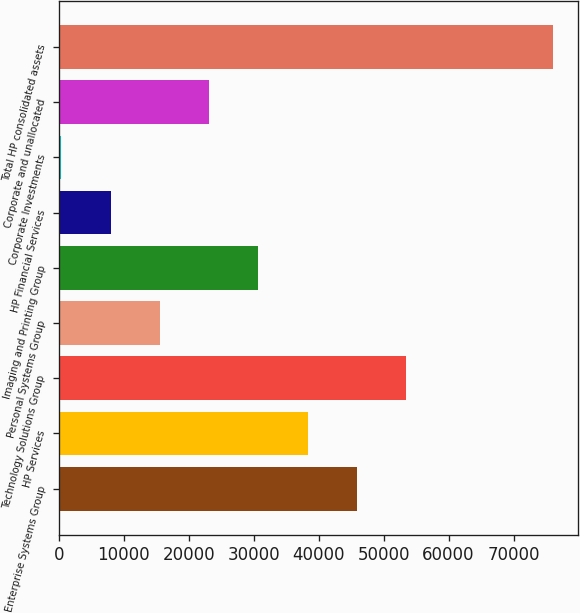<chart> <loc_0><loc_0><loc_500><loc_500><bar_chart><fcel>Enterprise Systems Group<fcel>HP Services<fcel>Technology Solutions Group<fcel>Personal Systems Group<fcel>Imaging and Printing Group<fcel>HP Financial Services<fcel>Corporate Investments<fcel>Corporate and unallocated<fcel>Total HP consolidated assets<nl><fcel>45873.5<fcel>38297.2<fcel>53449.8<fcel>15568.3<fcel>30720.9<fcel>7992<fcel>375<fcel>23144.6<fcel>76138<nl></chart> 